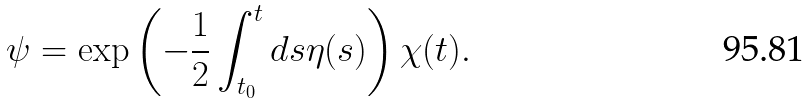<formula> <loc_0><loc_0><loc_500><loc_500>\psi = \exp \left ( - \frac { 1 } { 2 } \int _ { t _ { 0 } } ^ { t } d s \eta ( s ) \right ) \chi ( t ) .</formula> 